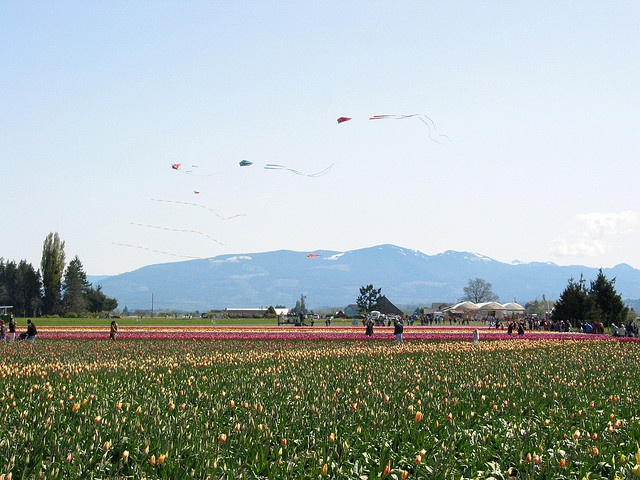Describe the objects in this image and their specific colors. I can see kite in lightblue, white, darkgray, and lightgray tones, kite in lightblue, lightgray, and darkgray tones, people in lightblue, black, gray, darkgreen, and brown tones, people in lightblue, black, gray, darkgreen, and navy tones, and people in lightblue, black, gray, blue, and darkgray tones in this image. 